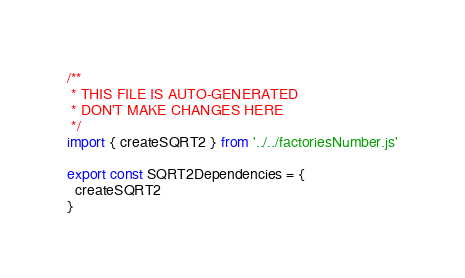<code> <loc_0><loc_0><loc_500><loc_500><_JavaScript_>/**
 * THIS FILE IS AUTO-GENERATED
 * DON'T MAKE CHANGES HERE
 */
import { createSQRT2 } from '../../factoriesNumber.js'

export const SQRT2Dependencies = {
  createSQRT2
}
</code> 